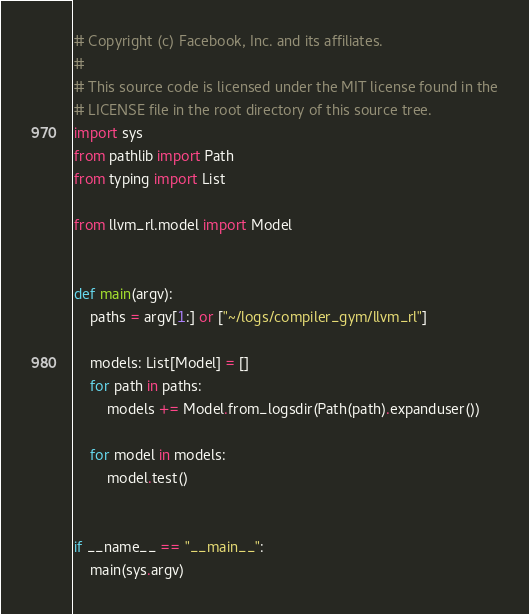Convert code to text. <code><loc_0><loc_0><loc_500><loc_500><_Python_># Copyright (c) Facebook, Inc. and its affiliates.
#
# This source code is licensed under the MIT license found in the
# LICENSE file in the root directory of this source tree.
import sys
from pathlib import Path
from typing import List

from llvm_rl.model import Model


def main(argv):
    paths = argv[1:] or ["~/logs/compiler_gym/llvm_rl"]

    models: List[Model] = []
    for path in paths:
        models += Model.from_logsdir(Path(path).expanduser())

    for model in models:
        model.test()


if __name__ == "__main__":
    main(sys.argv)
</code> 